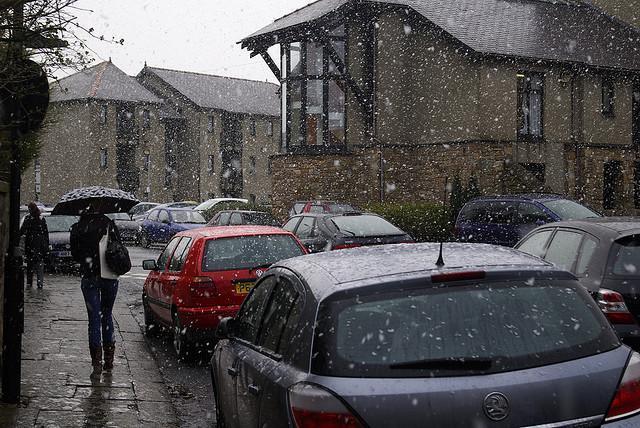How many people are visible?
Give a very brief answer. 2. How many cars are in the picture?
Give a very brief answer. 5. 